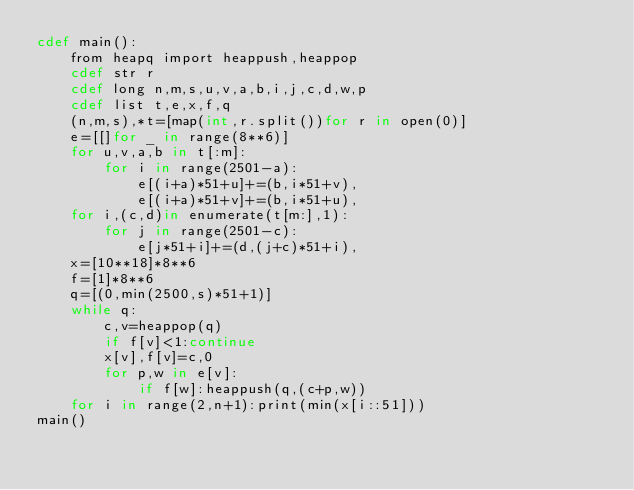Convert code to text. <code><loc_0><loc_0><loc_500><loc_500><_Cython_>cdef main():
    from heapq import heappush,heappop
    cdef str r
    cdef long n,m,s,u,v,a,b,i,j,c,d,w,p
    cdef list t,e,x,f,q
    (n,m,s),*t=[map(int,r.split())for r in open(0)]
    e=[[]for _ in range(8**6)]
    for u,v,a,b in t[:m]:
        for i in range(2501-a):
            e[(i+a)*51+u]+=(b,i*51+v),
            e[(i+a)*51+v]+=(b,i*51+u),
    for i,(c,d)in enumerate(t[m:],1):
        for j in range(2501-c):
            e[j*51+i]+=(d,(j+c)*51+i),
    x=[10**18]*8**6
    f=[1]*8**6
    q=[(0,min(2500,s)*51+1)]
    while q:
        c,v=heappop(q)
        if f[v]<1:continue
        x[v],f[v]=c,0
        for p,w in e[v]:
            if f[w]:heappush(q,(c+p,w))
    for i in range(2,n+1):print(min(x[i::51]))
main()</code> 